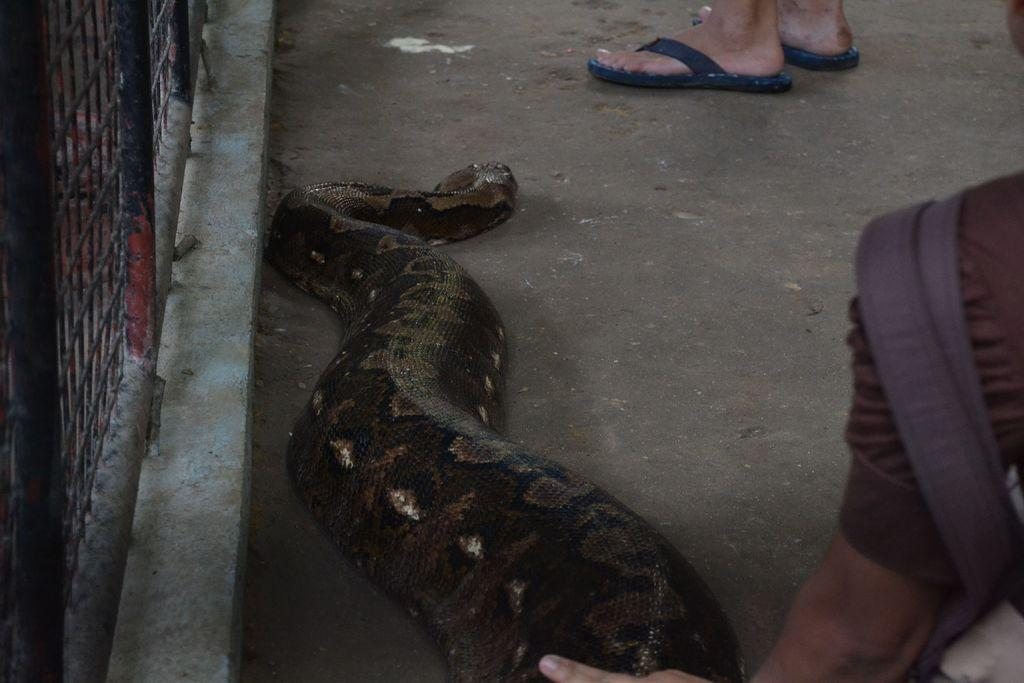What animal is the main subject of the image? There is a snake in the image. Where is the snake located in the image? The snake is in the middle of the image. What part of a person can be seen at the top of the image? There is a person's leg visible at the top of the image. Can you describe the person on the right side of the image? There is a person on the right side of the image. What type of dirt can be seen on the snake's skin in the image? There is no dirt visible on the snake's skin in the image. What type of secretary is present in the image? There is no secretary present in the image. 